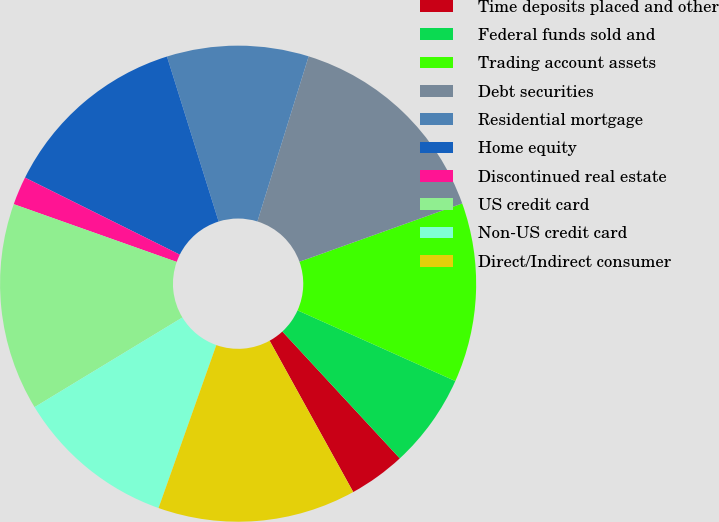<chart> <loc_0><loc_0><loc_500><loc_500><pie_chart><fcel>Time deposits placed and other<fcel>Federal funds sold and<fcel>Trading account assets<fcel>Debt securities<fcel>Residential mortgage<fcel>Home equity<fcel>Discontinued real estate<fcel>US credit card<fcel>Non-US credit card<fcel>Direct/Indirect consumer<nl><fcel>3.85%<fcel>6.41%<fcel>12.18%<fcel>14.74%<fcel>9.62%<fcel>12.82%<fcel>1.93%<fcel>14.1%<fcel>10.9%<fcel>13.46%<nl></chart> 